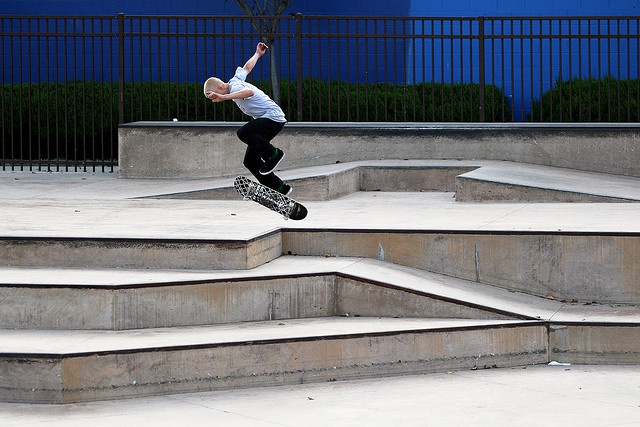Describe the objects in this image and their specific colors. I can see people in navy, black, white, darkgray, and gray tones and skateboard in navy, black, gray, darkgray, and lightgray tones in this image. 